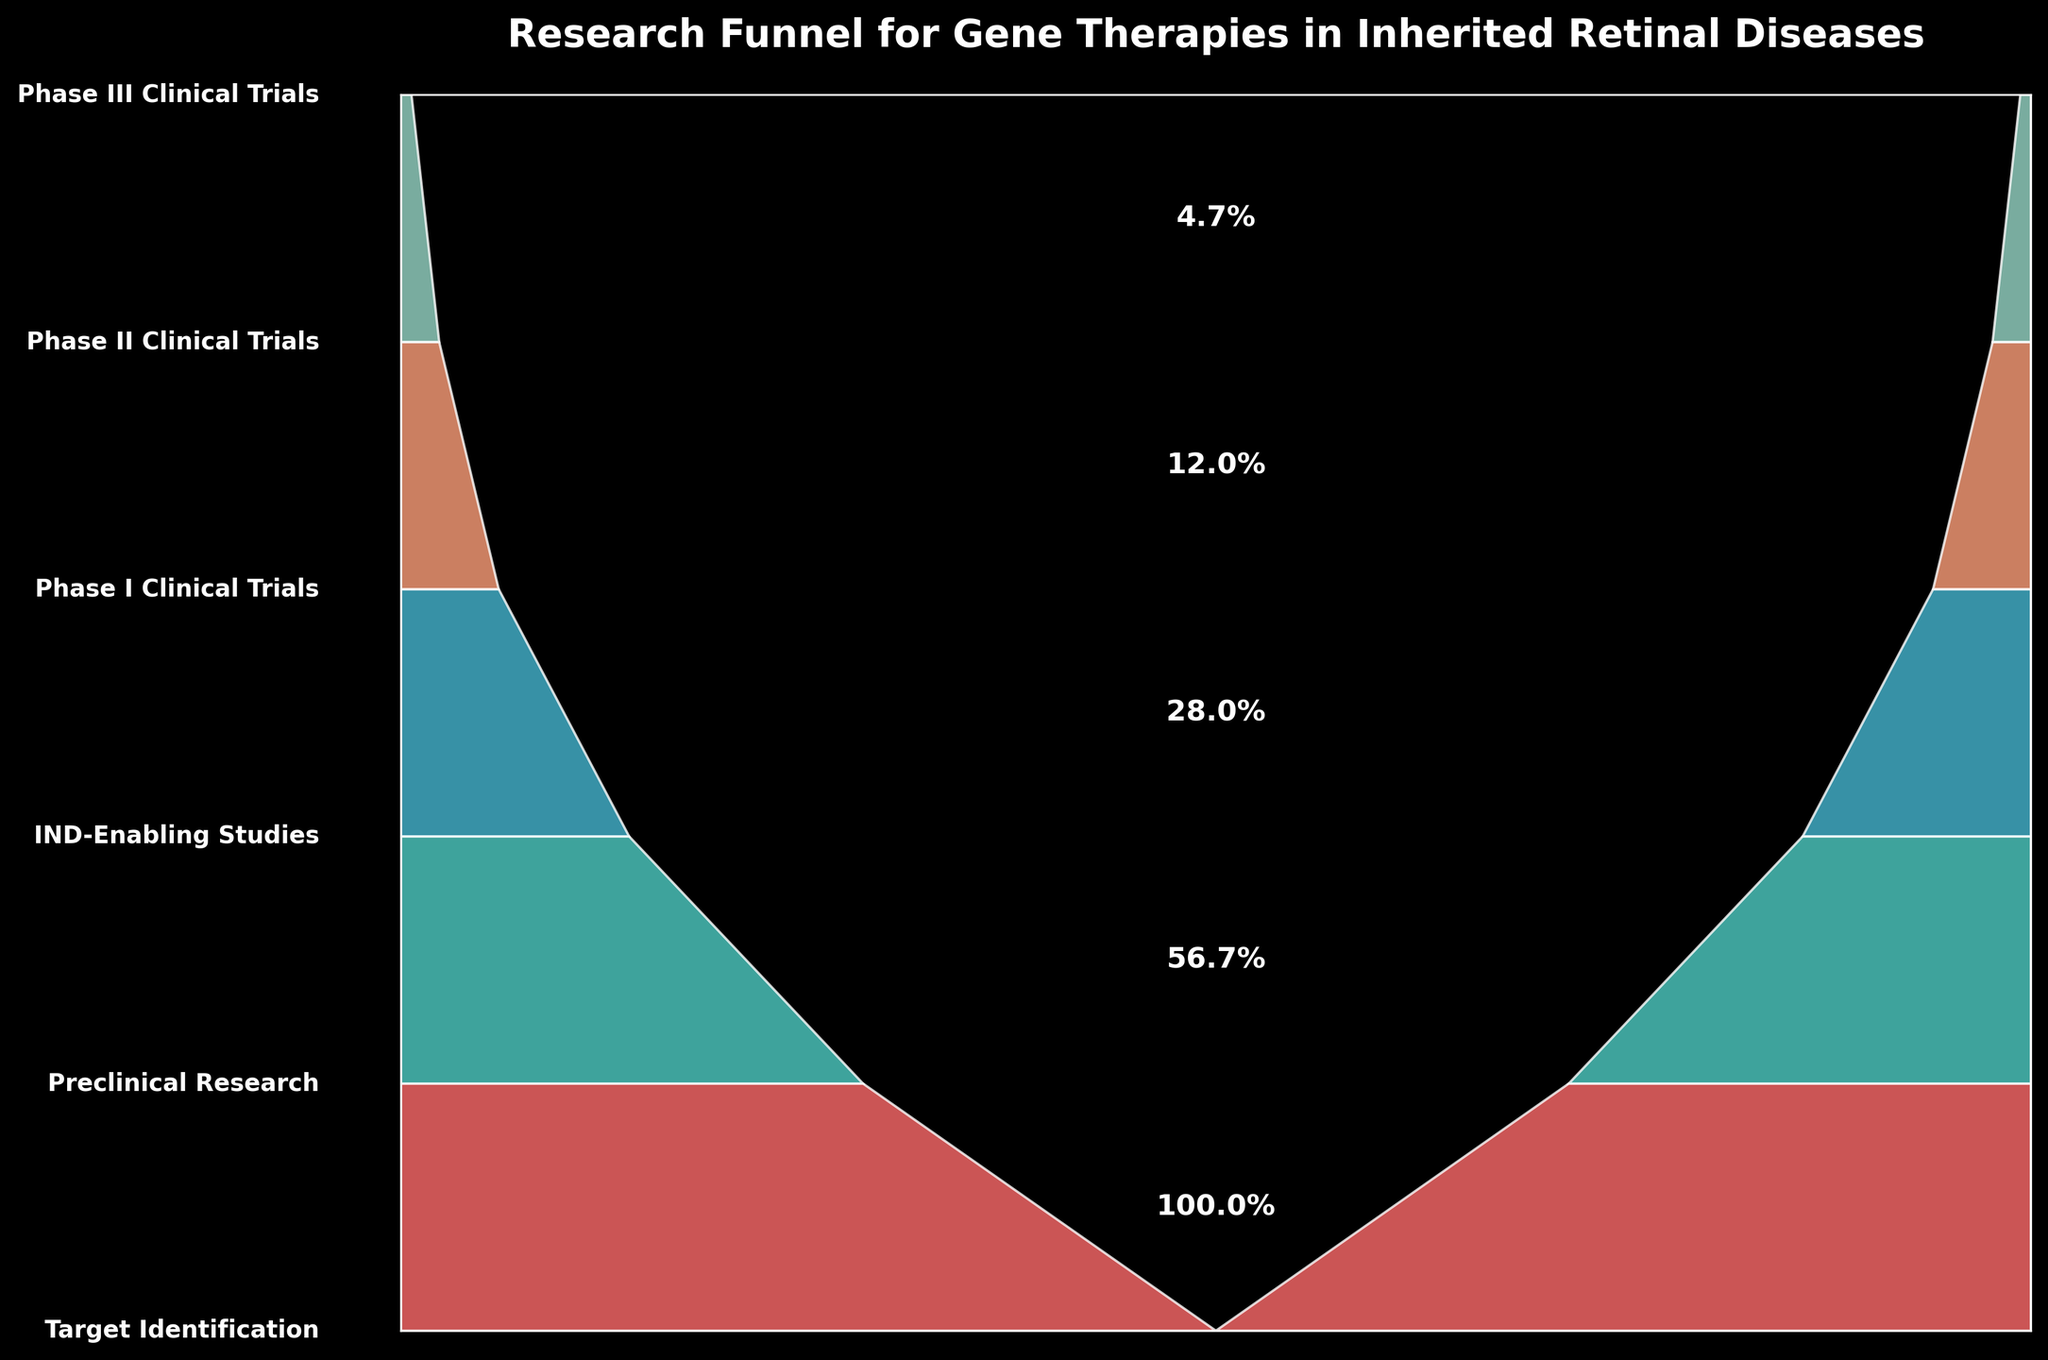What's the title of the chart? The title is usually positioned at the top of the figure, above the main content. The chart's title provides a brief overview of what the chart represents.
Answer: Research Funnel for Gene Therapies in Inherited Retinal Diseases How many stages are depicted in the funnel chart? Count the number of distinct stages labeled on the Y-axis or along the side of the chart. Each stage represents a step in the research process.
Answer: 6 What percentage of projects reach the Phase III Clinical Trials stage? Look at the label corresponding to the Phase III Clinical Trials stage. The percentage is explicitly mentioned next to this stage in the chart.
Answer: 1.3% Which stage has the highest percentage of projects? Identify the stage with the highest percentage by comparing the percentage values listed next to each stage. The one with the maximum percentage represents the initial stage.
Answer: Target Identification What is the percentage drop from Preclinical Research to IND-Enabling Studies? Calculate the difference between the percentages for Preclinical Research (56.7%) and IND-Enabling Studies (28%). The drop is the difference between these two values.
Answer: 28.7% How does the percentage of projects in Phase II Clinical Trials compare to those in Phase I Clinical Trials? Compare the percentage values of Phase II Clinical Trials (4.7%) and Phase I Clinical Trials (12%). Determine whether one is greater or lesser.
Answer: The percentage is less in Phase II Clinical Trials What is the ratio of projects in Phase I Clinical Trials to those in Phase III Clinical Trials? Take the number of projects in Phase I Clinical Trials (18) and divide it by the number of projects in Phase III Clinical Trials (2) to find the ratio.
Answer: 9:1 Which stage shows the largest percentage drop in projects compared to its previous stage? Calculate the percentage drop between consecutive stages and compare them. Find the pair of stages with the largest difference.
Answer: Preclinical Research to IND-Enabling Studies What visual elements are used to represent the different stages in the chart? Observe the design elements such as shapes, colors, and labels used in the figure that depict each stage of the funnel.
Answer: Polygons and colors 